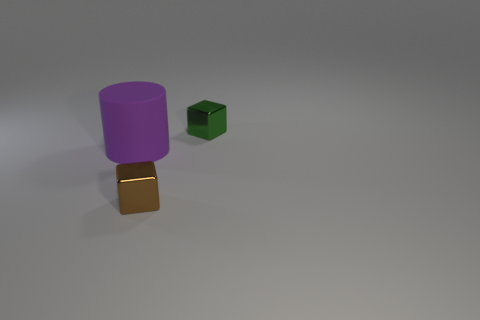How many things are behind the brown block and right of the big rubber object?
Ensure brevity in your answer.  1. There is a brown metal thing; is its shape the same as the thing that is on the left side of the tiny brown object?
Your answer should be very brief. No. Is the number of matte cylinders that are behind the brown shiny object greater than the number of large green matte objects?
Offer a very short reply. Yes. Is the number of green shiny things behind the green metal object less than the number of green metallic blocks?
Give a very brief answer. Yes. What is the object that is to the right of the cylinder and behind the small brown object made of?
Your response must be concise. Metal. How many green things are cubes or big balls?
Make the answer very short. 1. Are there fewer shiny things right of the brown metal block than things that are on the right side of the big purple object?
Make the answer very short. Yes. Are there any brown metal cylinders that have the same size as the brown object?
Your answer should be compact. No. Is the size of the object behind the matte thing the same as the purple object?
Make the answer very short. No. Is the number of small brown shiny cubes greater than the number of large red rubber cubes?
Keep it short and to the point. Yes. 